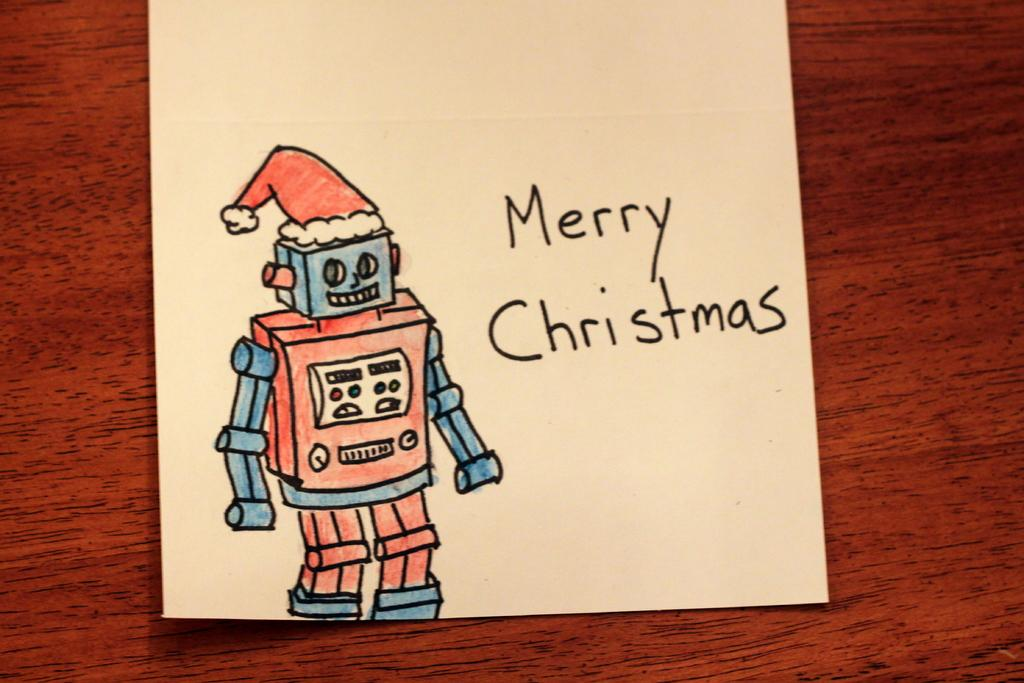What is depicted in the sketch in the image? There is a sketch of a robot in the image. What else can be seen in the image besides the sketch? There is something written on a paper in the image. On what type of surface is the paper placed? The paper is on a wooden surface. What type of bell is hanging from the arm of the robot in the image? There is no bell present in the image, and the robot's arm is not mentioned in the facts provided. 